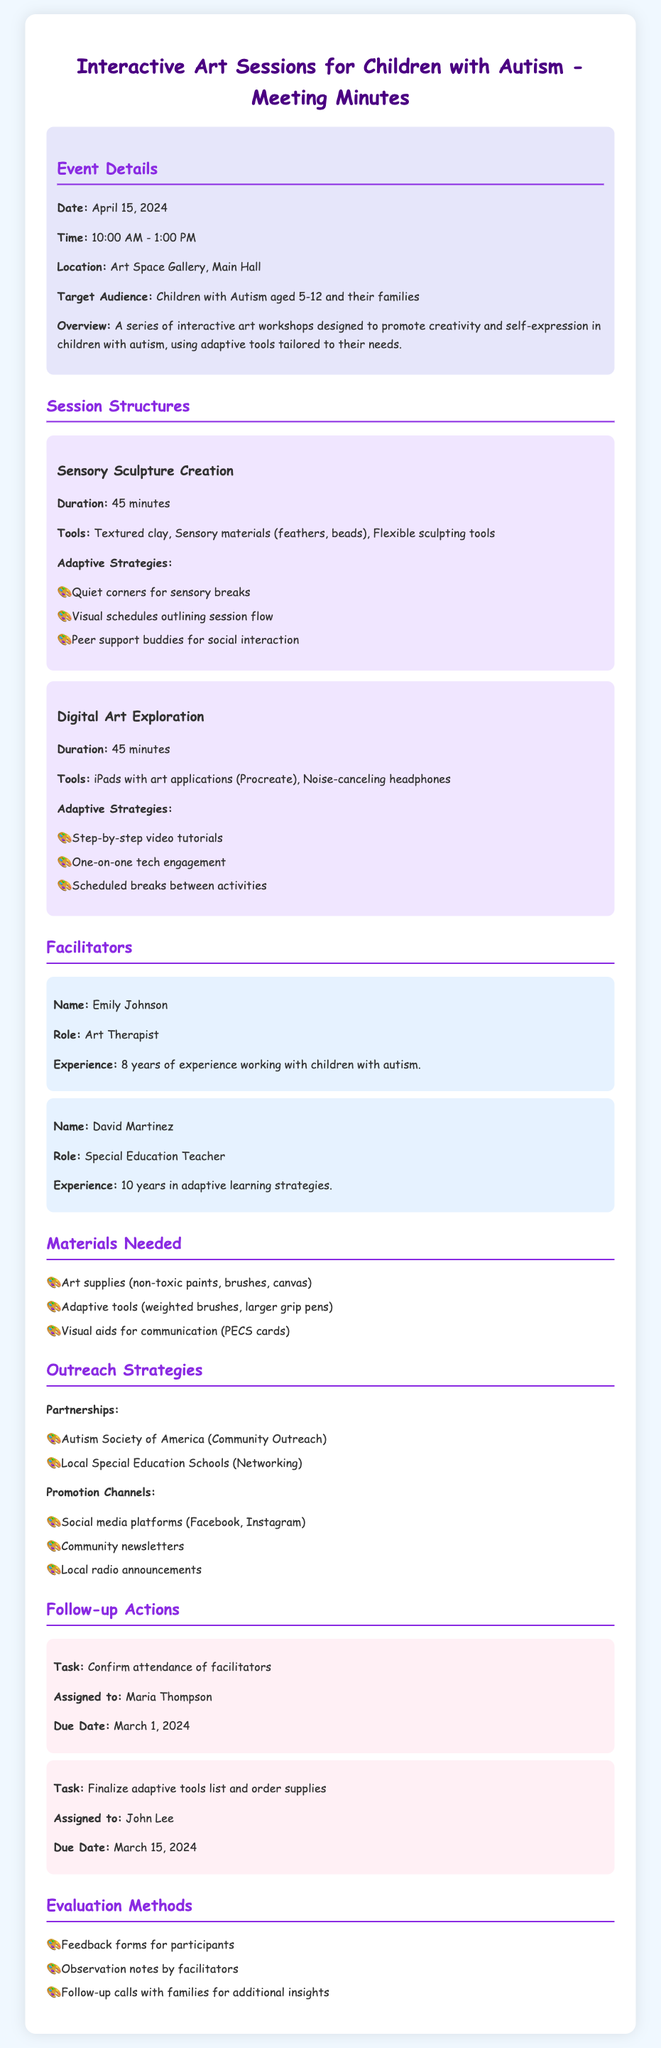What is the date of the event? The date of the event is mentioned in the event details section, which states it is scheduled for April 15, 2024.
Answer: April 15, 2024 What is the duration of the Sensory Sculpture Creation session? The duration of the Sensory Sculpture Creation session is listed in the session structures section, which indicates it lasts for 45 minutes.
Answer: 45 minutes Who is the Art Therapist facilitating the event? The facilitator section includes the name of the Art Therapist, which is Emily Johnson.
Answer: Emily Johnson What adaptive tools are specified for the Digital Art Exploration session? The tools for the Digital Art Exploration session are detailed in the session structures section, which includes iPads with art applications (Procreate) and noise-canceling headphones.
Answer: iPads with art applications (Procreate), noise-canceling headphones What promotional channels are listed for outreach? The outreach strategies section identifies various promotion channels, including social media platforms, community newsletters, and local radio announcements.
Answer: Social media platforms, community newsletters, local radio announcements Who is responsible for confirming the attendance of facilitators? The follow-up actions section specifies the assigned person for the task of confirming facilitators' attendance, which is Maria Thompson.
Answer: Maria Thompson What type of feedback will be collected post-event? The evaluation methods section mentions feedback forms, observation notes by facilitators, and follow-up calls with families as methods for collecting feedback post-event.
Answer: Feedback forms for participants What is the target audience for the event? The event details highlight that the target audience is children with autism aged 5-12 and their families.
Answer: Children with Autism aged 5-12 and their families What is one adaptive strategy for the Sensory Sculpture Creation session? The session structures section of the document lists several adaptive strategies, one of which is quiet corners for sensory breaks.
Answer: Quiet corners for sensory breaks 